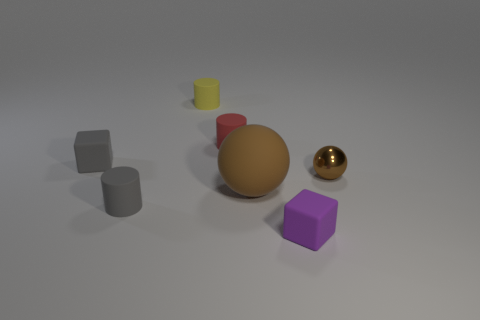What number of yellow things have the same size as the purple rubber object?
Make the answer very short. 1. There is another object that is the same color as the big object; what is its shape?
Ensure brevity in your answer.  Sphere. Is there a red thing to the left of the cylinder right of the yellow rubber cylinder?
Make the answer very short. No. How many things are either small rubber cubes that are on the right side of the large matte sphere or gray rubber objects?
Your answer should be compact. 3. What number of things are there?
Give a very brief answer. 7. What is the shape of the yellow object that is the same material as the small gray cylinder?
Make the answer very short. Cylinder. What is the size of the matte object that is on the left side of the matte cylinder in front of the brown matte ball?
Keep it short and to the point. Small. How many objects are either things that are in front of the tiny gray cylinder or tiny objects in front of the yellow cylinder?
Offer a terse response. 5. Is the number of tiny matte objects less than the number of big yellow matte objects?
Give a very brief answer. No. What number of objects are either small purple objects or big brown metal things?
Keep it short and to the point. 1. 